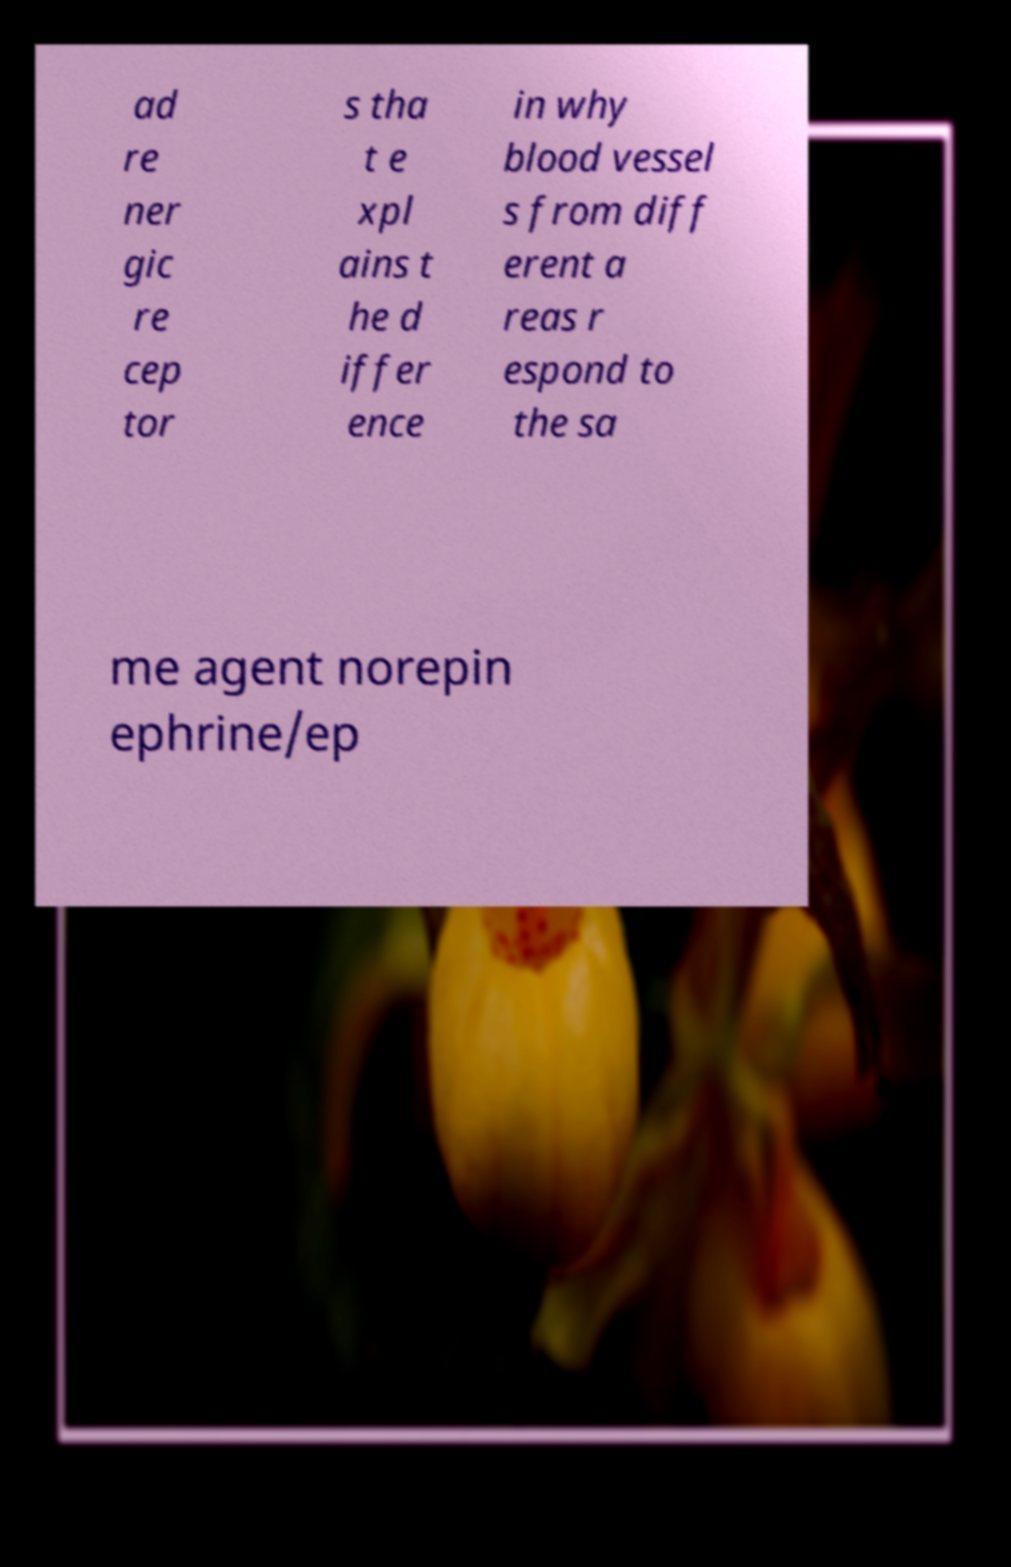I need the written content from this picture converted into text. Can you do that? ad re ner gic re cep tor s tha t e xpl ains t he d iffer ence in why blood vessel s from diff erent a reas r espond to the sa me agent norepin ephrine/ep 